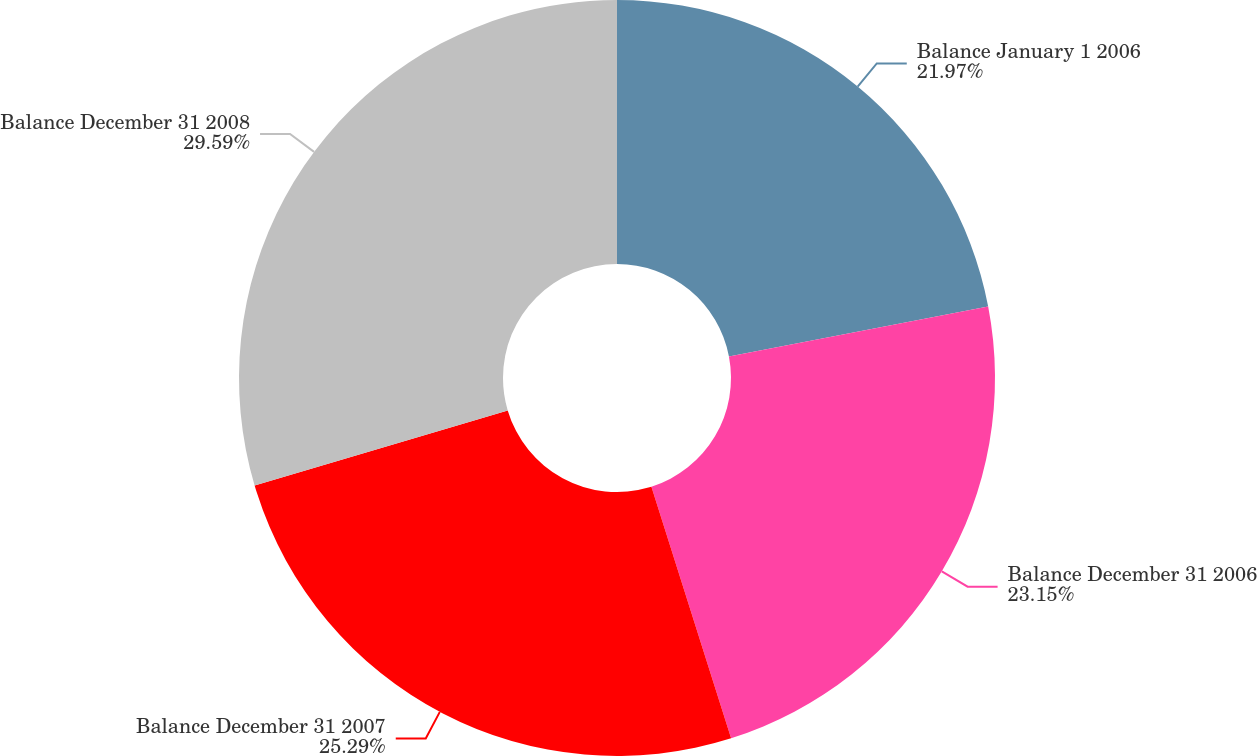<chart> <loc_0><loc_0><loc_500><loc_500><pie_chart><fcel>Balance January 1 2006<fcel>Balance December 31 2006<fcel>Balance December 31 2007<fcel>Balance December 31 2008<nl><fcel>21.97%<fcel>23.15%<fcel>25.29%<fcel>29.59%<nl></chart> 